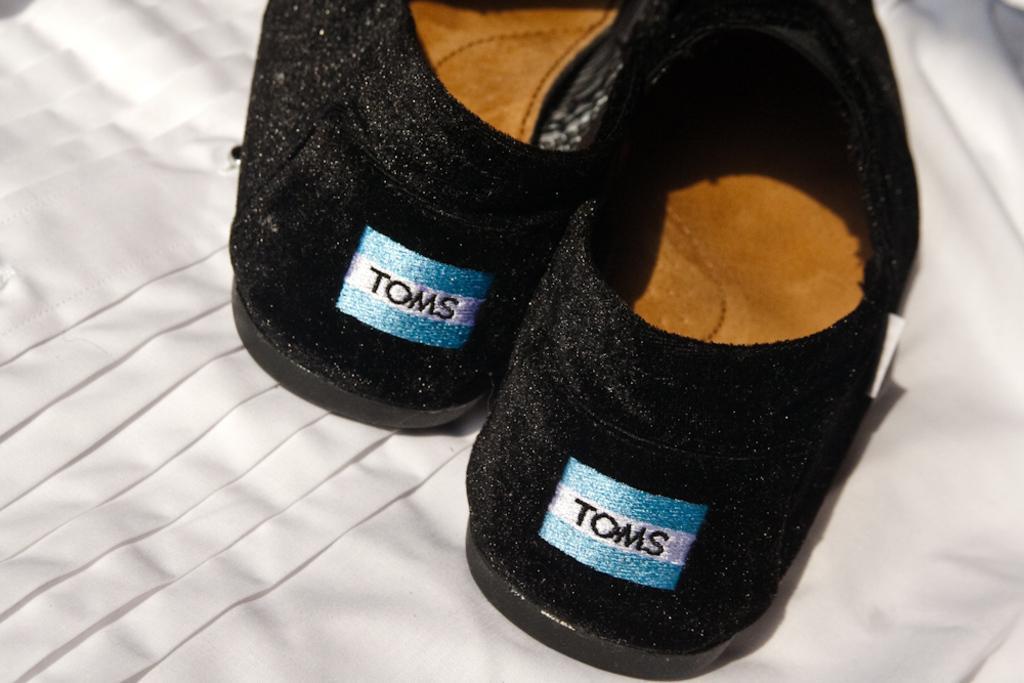Could you give a brief overview of what you see in this image? As we can see in the image there is a white color cloth and black color shoes. 